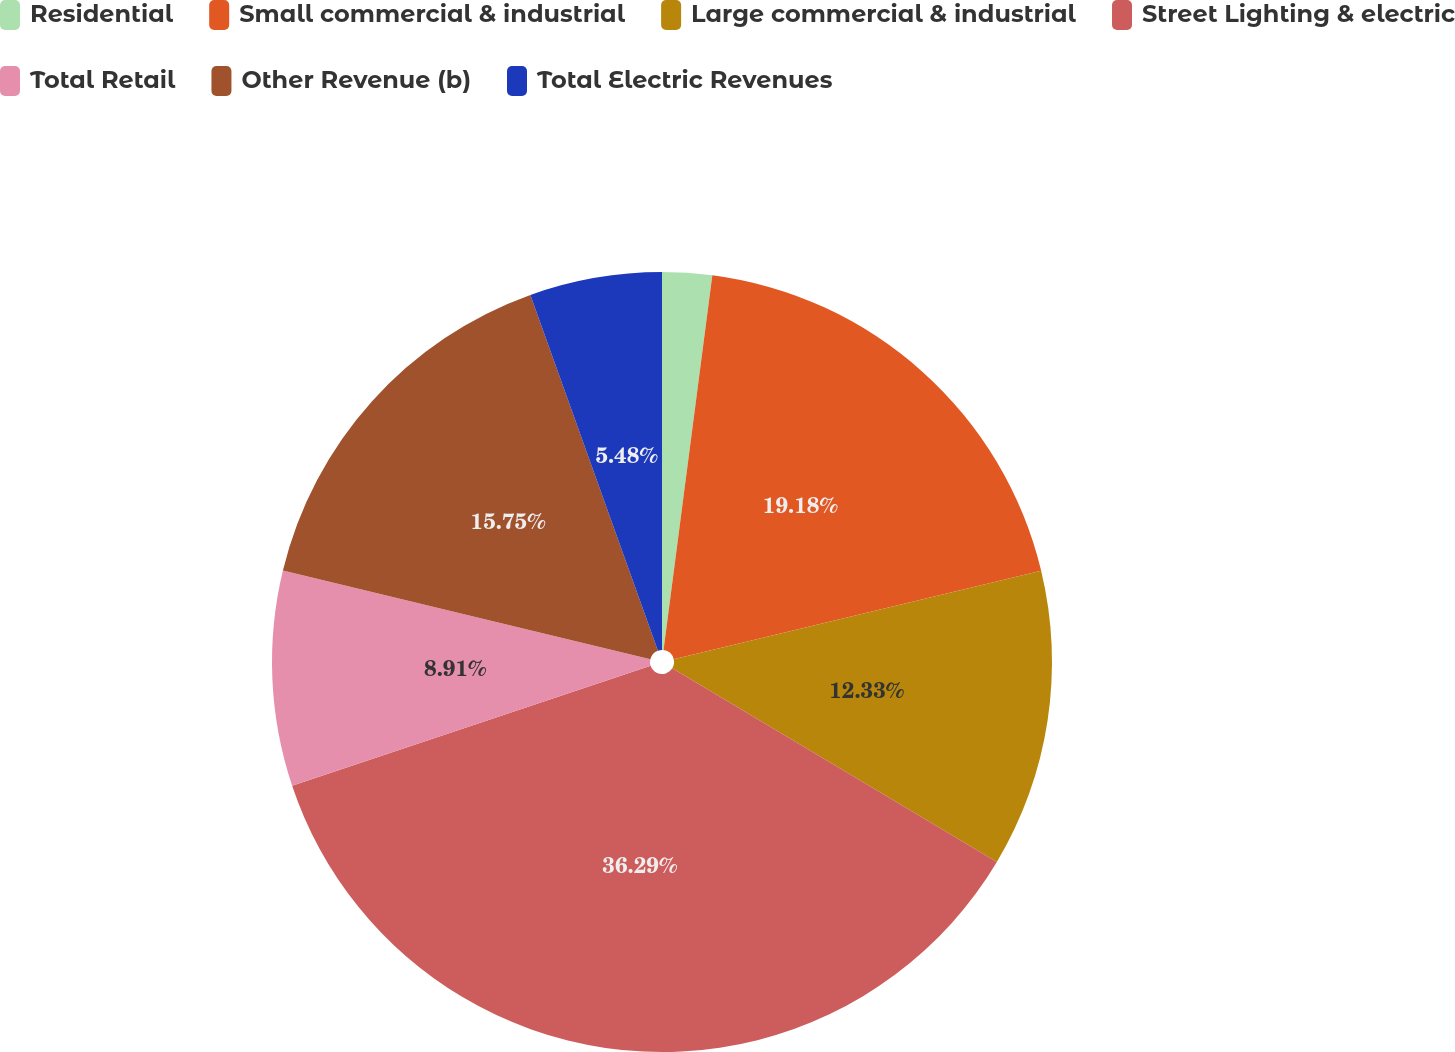Convert chart. <chart><loc_0><loc_0><loc_500><loc_500><pie_chart><fcel>Residential<fcel>Small commercial & industrial<fcel>Large commercial & industrial<fcel>Street Lighting & electric<fcel>Total Retail<fcel>Other Revenue (b)<fcel>Total Electric Revenues<nl><fcel>2.06%<fcel>19.18%<fcel>12.33%<fcel>36.3%<fcel>8.91%<fcel>15.75%<fcel>5.48%<nl></chart> 